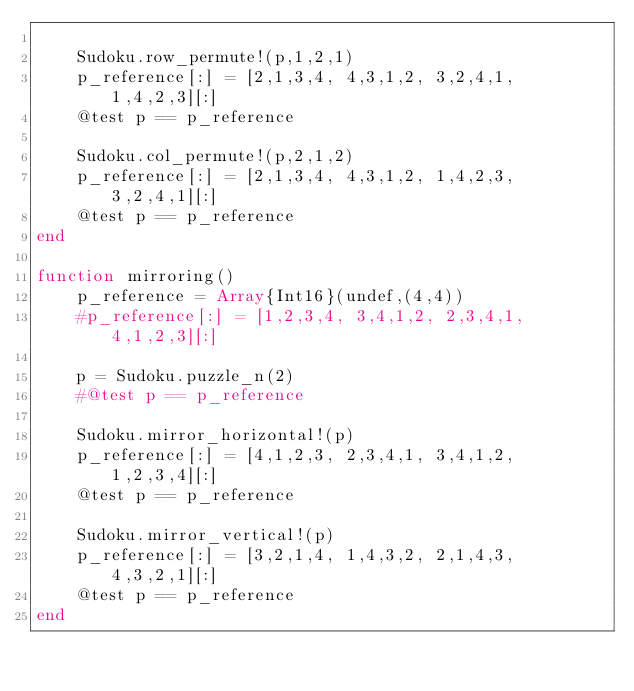Convert code to text. <code><loc_0><loc_0><loc_500><loc_500><_Julia_>    
    Sudoku.row_permute!(p,1,2,1)
    p_reference[:] = [2,1,3,4, 4,3,1,2, 3,2,4,1, 1,4,2,3][:]
    @test p == p_reference

    Sudoku.col_permute!(p,2,1,2)
    p_reference[:] = [2,1,3,4, 4,3,1,2, 1,4,2,3, 3,2,4,1][:]
    @test p == p_reference
end

function mirroring()
    p_reference = Array{Int16}(undef,(4,4))
    #p_reference[:] = [1,2,3,4, 3,4,1,2, 2,3,4,1, 4,1,2,3][:]
    
    p = Sudoku.puzzle_n(2)
    #@test p == p_reference 
    
    Sudoku.mirror_horizontal!(p)
    p_reference[:] = [4,1,2,3, 2,3,4,1, 3,4,1,2, 1,2,3,4][:]
    @test p == p_reference

    Sudoku.mirror_vertical!(p)
    p_reference[:] = [3,2,1,4, 1,4,3,2, 2,1,4,3, 4,3,2,1][:]
    @test p == p_reference
end</code> 